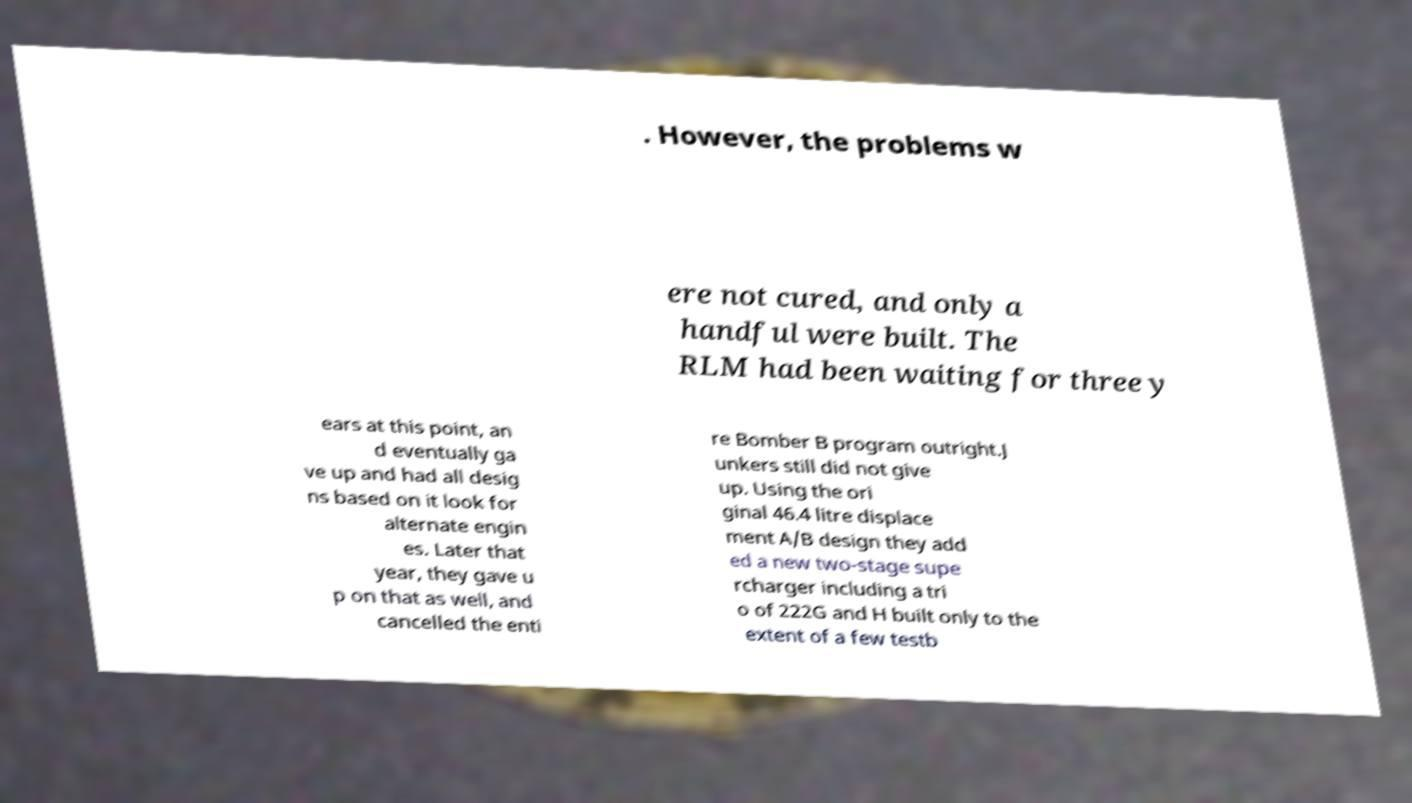There's text embedded in this image that I need extracted. Can you transcribe it verbatim? . However, the problems w ere not cured, and only a handful were built. The RLM had been waiting for three y ears at this point, an d eventually ga ve up and had all desig ns based on it look for alternate engin es. Later that year, they gave u p on that as well, and cancelled the enti re Bomber B program outright.J unkers still did not give up. Using the ori ginal 46.4 litre displace ment A/B design they add ed a new two-stage supe rcharger including a tri o of 222G and H built only to the extent of a few testb 